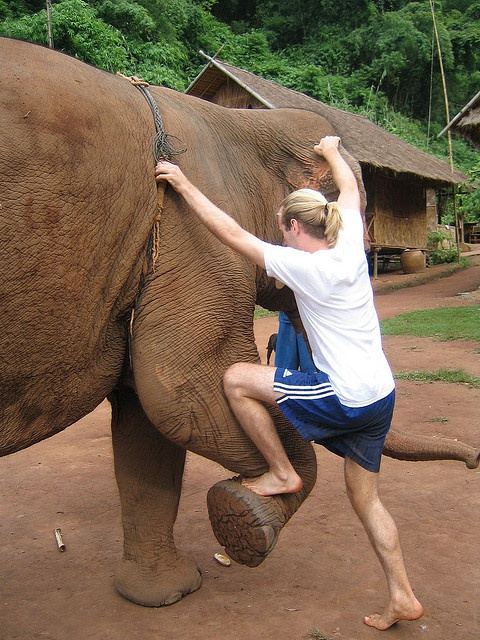Describe the objects in this image and their specific colors. I can see elephant in darkgreen, gray, brown, maroon, and black tones and people in darkgreen, white, tan, gray, and black tones in this image. 